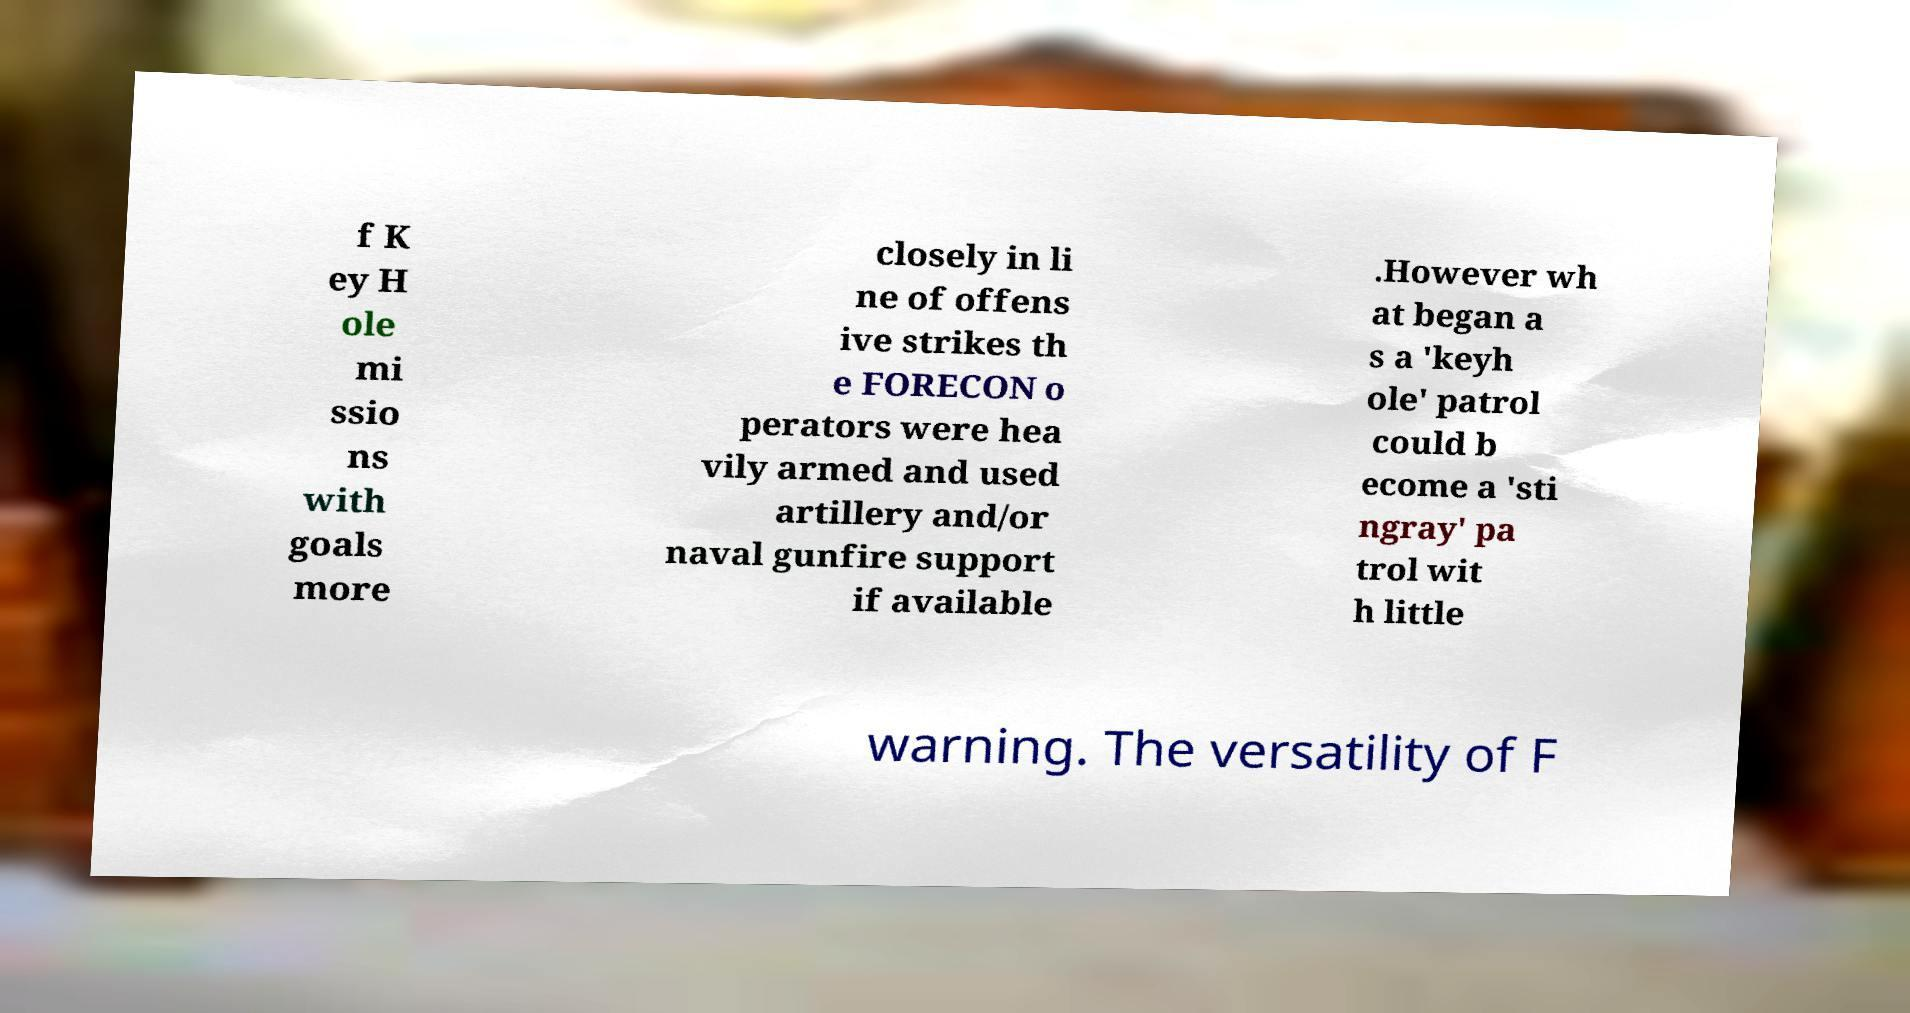For documentation purposes, I need the text within this image transcribed. Could you provide that? f K ey H ole mi ssio ns with goals more closely in li ne of offens ive strikes th e FORECON o perators were hea vily armed and used artillery and/or naval gunfire support if available .However wh at began a s a 'keyh ole' patrol could b ecome a 'sti ngray' pa trol wit h little warning. The versatility of F 